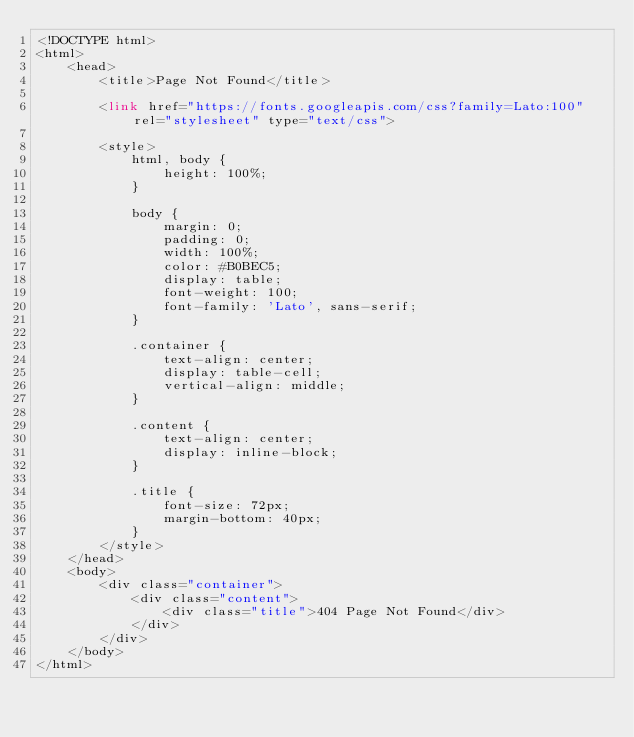Convert code to text. <code><loc_0><loc_0><loc_500><loc_500><_PHP_><!DOCTYPE html>
<html>
    <head>
        <title>Page Not Found</title>

        <link href="https://fonts.googleapis.com/css?family=Lato:100" rel="stylesheet" type="text/css">

        <style>
            html, body {
                height: 100%;
            }

            body {
                margin: 0;
                padding: 0;
                width: 100%;
                color: #B0BEC5;
                display: table;
                font-weight: 100;
                font-family: 'Lato', sans-serif;
            }

            .container {
                text-align: center;
                display: table-cell;
                vertical-align: middle;
            }

            .content {
                text-align: center;
                display: inline-block;
            }

            .title {
                font-size: 72px;
                margin-bottom: 40px;
            }
        </style>
    </head>
    <body>
        <div class="container">
            <div class="content">
                <div class="title">404 Page Not Found</div>
            </div>
        </div>
    </body>
</html>
</code> 